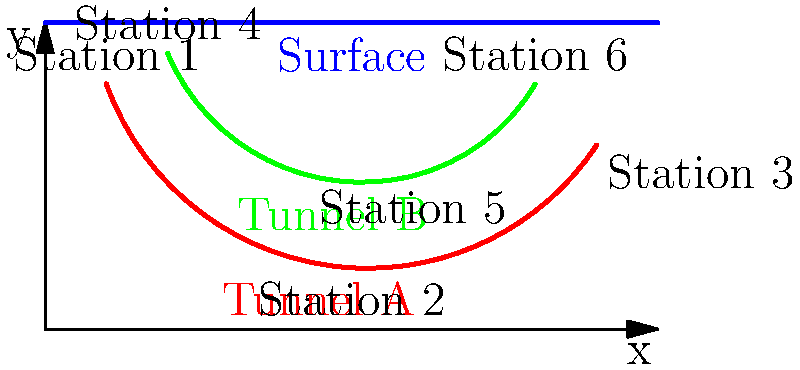During your daily Metro ride, you notice a map of the underground tunnel system. The diagram shows two tunnels (A and B) connecting various stations. If you were to write a report on the Metro's topology, which mathematical concept would best describe the relationship between the surface-level representation and the actual underground path of Tunnel A? To answer this question, let's analyze the topology of Tunnel A step-by-step:

1. Observe the path of Tunnel A (red line) in relation to the surface level (blue line).

2. Notice that Tunnel A starts near the surface at Station 1, then dips down significantly before rising again to approach the surface at Station 3.

3. This curved path of Tunnel A can be represented mathematically as a continuous function.

4. The surface-level representation of Tunnel A would be a straight line connecting Station 1 and Station 3.

5. The relationship between the actual tunnel path and its surface representation can be described using the concept of a projection.

6. In topology, a projection is a mapping of a set (or a geometric object) onto a subset of itself or onto a lower-dimensional space.

7. In this case, the 2D curved path of Tunnel A is being projected onto a 1D straight line on the surface.

8. This projection preserves the connectivity between the start and end points (Station 1 and Station 3) but loses information about the depth and curvature of the actual tunnel.

Given these observations, the mathematical concept that best describes this relationship is a topological projection.
Answer: Topological projection 